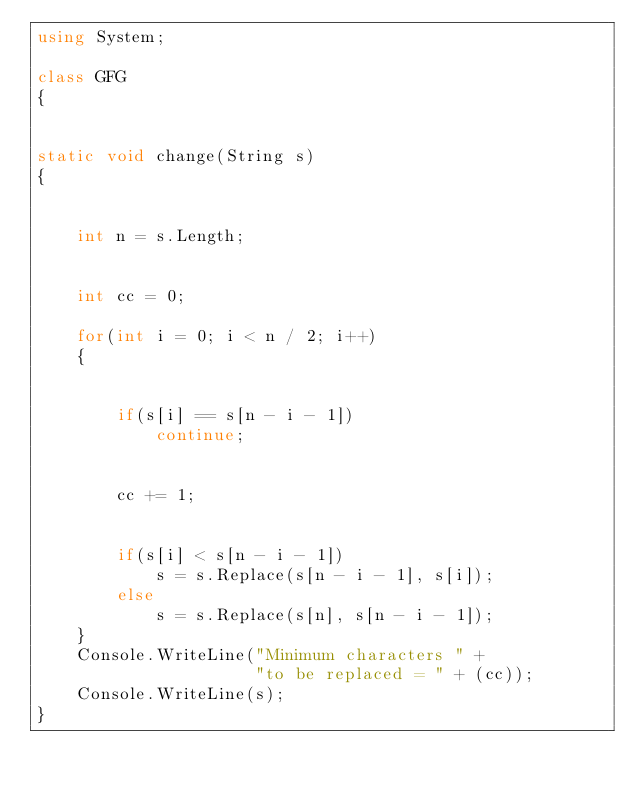<code> <loc_0><loc_0><loc_500><loc_500><_C#_>using System;  
      
class GFG 
{ 
  
  
static void change(String s) 
{ 
  
     
    int n = s.Length;  
  
     
    int cc = 0; 
  
    for(int i = 0; i < n / 2; i++) 
    { 
  
         
        if(s[i] == s[n - i - 1])  
            continue; 
  
        
        cc += 1; 
  
       
        if(s[i] < s[n - i - 1])  
            s = s.Replace(s[n - i - 1], s[i]); 
        else
            s = s.Replace(s[n], s[n - i - 1]); 
    } 
    Console.WriteLine("Minimum characters " +  
                      "to be replaced = " + (cc)); 
    Console.WriteLine(s);  
} </code> 